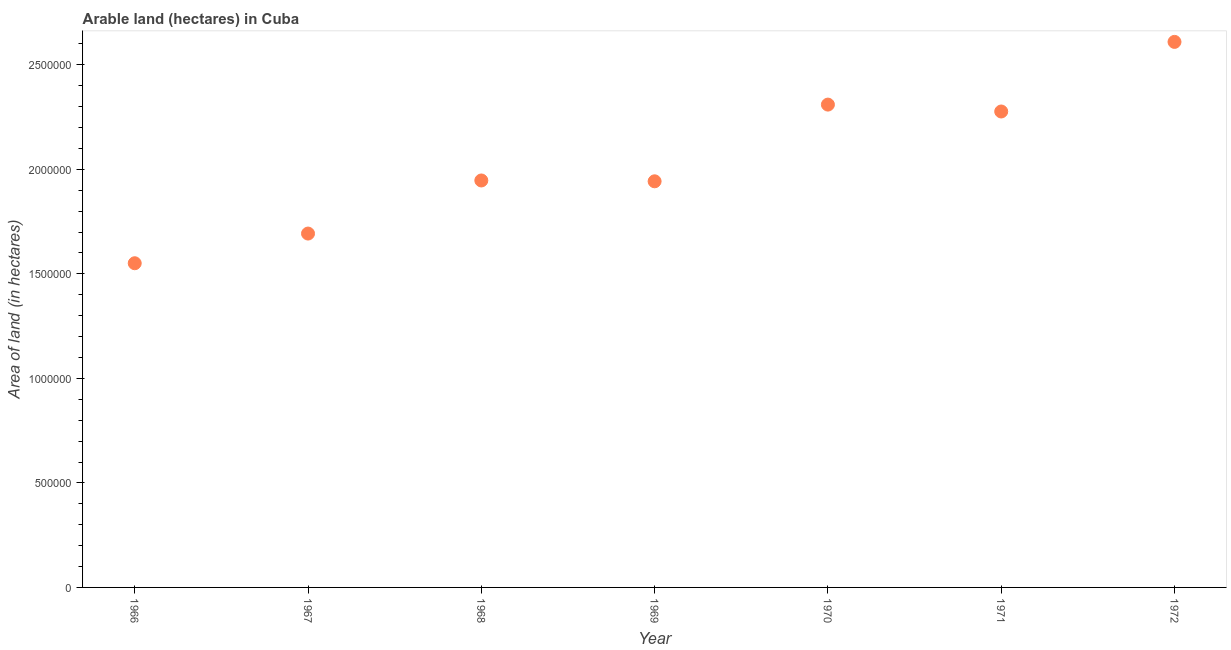What is the area of land in 1970?
Provide a succinct answer. 2.31e+06. Across all years, what is the maximum area of land?
Offer a terse response. 2.61e+06. Across all years, what is the minimum area of land?
Offer a very short reply. 1.55e+06. In which year was the area of land maximum?
Offer a very short reply. 1972. In which year was the area of land minimum?
Offer a terse response. 1966. What is the sum of the area of land?
Provide a short and direct response. 1.43e+07. What is the difference between the area of land in 1969 and 1972?
Your response must be concise. -6.67e+05. What is the average area of land per year?
Offer a very short reply. 2.05e+06. What is the median area of land?
Keep it short and to the point. 1.95e+06. In how many years, is the area of land greater than 500000 hectares?
Provide a short and direct response. 7. Do a majority of the years between 1966 and 1971 (inclusive) have area of land greater than 2500000 hectares?
Provide a succinct answer. No. What is the ratio of the area of land in 1966 to that in 1969?
Give a very brief answer. 0.8. Is the difference between the area of land in 1968 and 1970 greater than the difference between any two years?
Your response must be concise. No. What is the difference between the highest and the second highest area of land?
Offer a terse response. 3.00e+05. What is the difference between the highest and the lowest area of land?
Make the answer very short. 1.06e+06. Does the area of land monotonically increase over the years?
Your answer should be very brief. No. Are the values on the major ticks of Y-axis written in scientific E-notation?
Your response must be concise. No. Does the graph contain grids?
Offer a very short reply. No. What is the title of the graph?
Make the answer very short. Arable land (hectares) in Cuba. What is the label or title of the Y-axis?
Offer a very short reply. Area of land (in hectares). What is the Area of land (in hectares) in 1966?
Provide a succinct answer. 1.55e+06. What is the Area of land (in hectares) in 1967?
Make the answer very short. 1.69e+06. What is the Area of land (in hectares) in 1968?
Your response must be concise. 1.95e+06. What is the Area of land (in hectares) in 1969?
Ensure brevity in your answer.  1.94e+06. What is the Area of land (in hectares) in 1970?
Offer a terse response. 2.31e+06. What is the Area of land (in hectares) in 1971?
Provide a short and direct response. 2.28e+06. What is the Area of land (in hectares) in 1972?
Ensure brevity in your answer.  2.61e+06. What is the difference between the Area of land (in hectares) in 1966 and 1967?
Provide a short and direct response. -1.42e+05. What is the difference between the Area of land (in hectares) in 1966 and 1968?
Provide a short and direct response. -3.96e+05. What is the difference between the Area of land (in hectares) in 1966 and 1969?
Offer a terse response. -3.92e+05. What is the difference between the Area of land (in hectares) in 1966 and 1970?
Offer a very short reply. -7.59e+05. What is the difference between the Area of land (in hectares) in 1966 and 1971?
Give a very brief answer. -7.26e+05. What is the difference between the Area of land (in hectares) in 1966 and 1972?
Offer a very short reply. -1.06e+06. What is the difference between the Area of land (in hectares) in 1967 and 1968?
Provide a succinct answer. -2.54e+05. What is the difference between the Area of land (in hectares) in 1967 and 1969?
Provide a short and direct response. -2.50e+05. What is the difference between the Area of land (in hectares) in 1967 and 1970?
Make the answer very short. -6.17e+05. What is the difference between the Area of land (in hectares) in 1967 and 1971?
Give a very brief answer. -5.84e+05. What is the difference between the Area of land (in hectares) in 1967 and 1972?
Your answer should be very brief. -9.17e+05. What is the difference between the Area of land (in hectares) in 1968 and 1969?
Your response must be concise. 4000. What is the difference between the Area of land (in hectares) in 1968 and 1970?
Keep it short and to the point. -3.63e+05. What is the difference between the Area of land (in hectares) in 1968 and 1971?
Ensure brevity in your answer.  -3.30e+05. What is the difference between the Area of land (in hectares) in 1968 and 1972?
Offer a very short reply. -6.63e+05. What is the difference between the Area of land (in hectares) in 1969 and 1970?
Give a very brief answer. -3.67e+05. What is the difference between the Area of land (in hectares) in 1969 and 1971?
Make the answer very short. -3.34e+05. What is the difference between the Area of land (in hectares) in 1969 and 1972?
Offer a very short reply. -6.67e+05. What is the difference between the Area of land (in hectares) in 1970 and 1971?
Your answer should be compact. 3.30e+04. What is the difference between the Area of land (in hectares) in 1970 and 1972?
Your answer should be compact. -3.00e+05. What is the difference between the Area of land (in hectares) in 1971 and 1972?
Your answer should be very brief. -3.33e+05. What is the ratio of the Area of land (in hectares) in 1966 to that in 1967?
Keep it short and to the point. 0.92. What is the ratio of the Area of land (in hectares) in 1966 to that in 1968?
Your response must be concise. 0.8. What is the ratio of the Area of land (in hectares) in 1966 to that in 1969?
Provide a short and direct response. 0.8. What is the ratio of the Area of land (in hectares) in 1966 to that in 1970?
Offer a terse response. 0.67. What is the ratio of the Area of land (in hectares) in 1966 to that in 1971?
Your answer should be very brief. 0.68. What is the ratio of the Area of land (in hectares) in 1966 to that in 1972?
Give a very brief answer. 0.59. What is the ratio of the Area of land (in hectares) in 1967 to that in 1968?
Your response must be concise. 0.87. What is the ratio of the Area of land (in hectares) in 1967 to that in 1969?
Your answer should be compact. 0.87. What is the ratio of the Area of land (in hectares) in 1967 to that in 1970?
Provide a succinct answer. 0.73. What is the ratio of the Area of land (in hectares) in 1967 to that in 1971?
Your answer should be very brief. 0.74. What is the ratio of the Area of land (in hectares) in 1967 to that in 1972?
Provide a short and direct response. 0.65. What is the ratio of the Area of land (in hectares) in 1968 to that in 1969?
Give a very brief answer. 1. What is the ratio of the Area of land (in hectares) in 1968 to that in 1970?
Your response must be concise. 0.84. What is the ratio of the Area of land (in hectares) in 1968 to that in 1971?
Your answer should be compact. 0.85. What is the ratio of the Area of land (in hectares) in 1968 to that in 1972?
Offer a terse response. 0.75. What is the ratio of the Area of land (in hectares) in 1969 to that in 1970?
Keep it short and to the point. 0.84. What is the ratio of the Area of land (in hectares) in 1969 to that in 1971?
Give a very brief answer. 0.85. What is the ratio of the Area of land (in hectares) in 1969 to that in 1972?
Your answer should be compact. 0.74. What is the ratio of the Area of land (in hectares) in 1970 to that in 1972?
Your response must be concise. 0.89. What is the ratio of the Area of land (in hectares) in 1971 to that in 1972?
Provide a short and direct response. 0.87. 